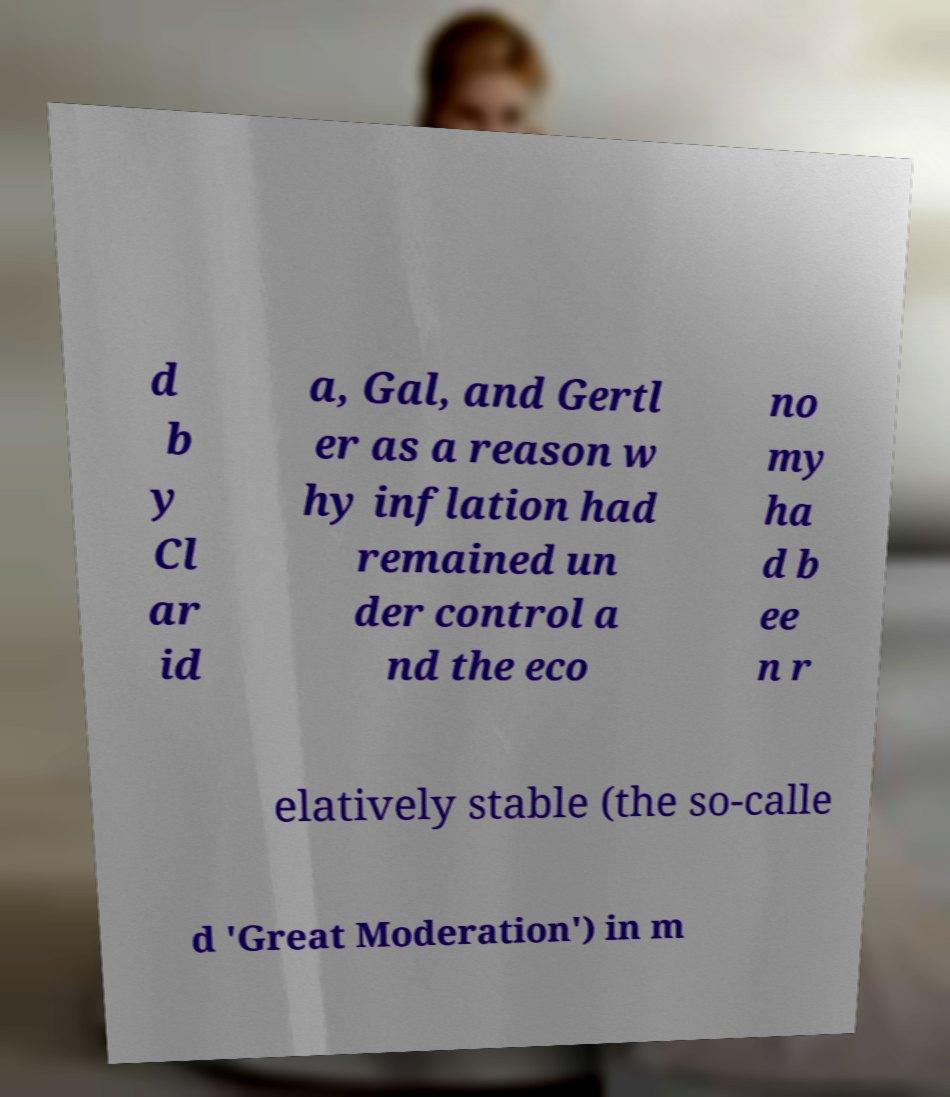Please read and relay the text visible in this image. What does it say? d b y Cl ar id a, Gal, and Gertl er as a reason w hy inflation had remained un der control a nd the eco no my ha d b ee n r elatively stable (the so-calle d 'Great Moderation') in m 